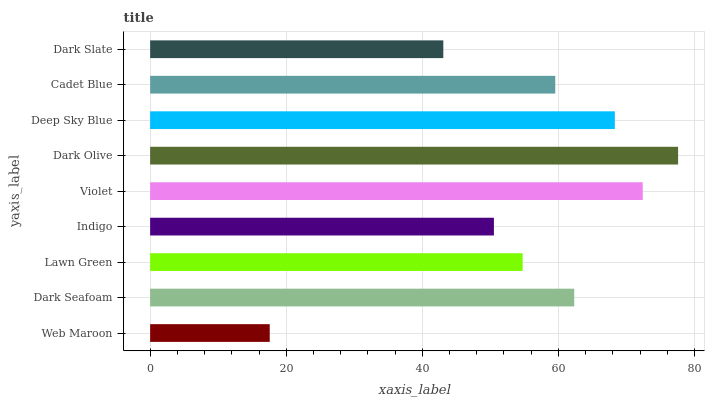Is Web Maroon the minimum?
Answer yes or no. Yes. Is Dark Olive the maximum?
Answer yes or no. Yes. Is Dark Seafoam the minimum?
Answer yes or no. No. Is Dark Seafoam the maximum?
Answer yes or no. No. Is Dark Seafoam greater than Web Maroon?
Answer yes or no. Yes. Is Web Maroon less than Dark Seafoam?
Answer yes or no. Yes. Is Web Maroon greater than Dark Seafoam?
Answer yes or no. No. Is Dark Seafoam less than Web Maroon?
Answer yes or no. No. Is Cadet Blue the high median?
Answer yes or no. Yes. Is Cadet Blue the low median?
Answer yes or no. Yes. Is Indigo the high median?
Answer yes or no. No. Is Dark Seafoam the low median?
Answer yes or no. No. 